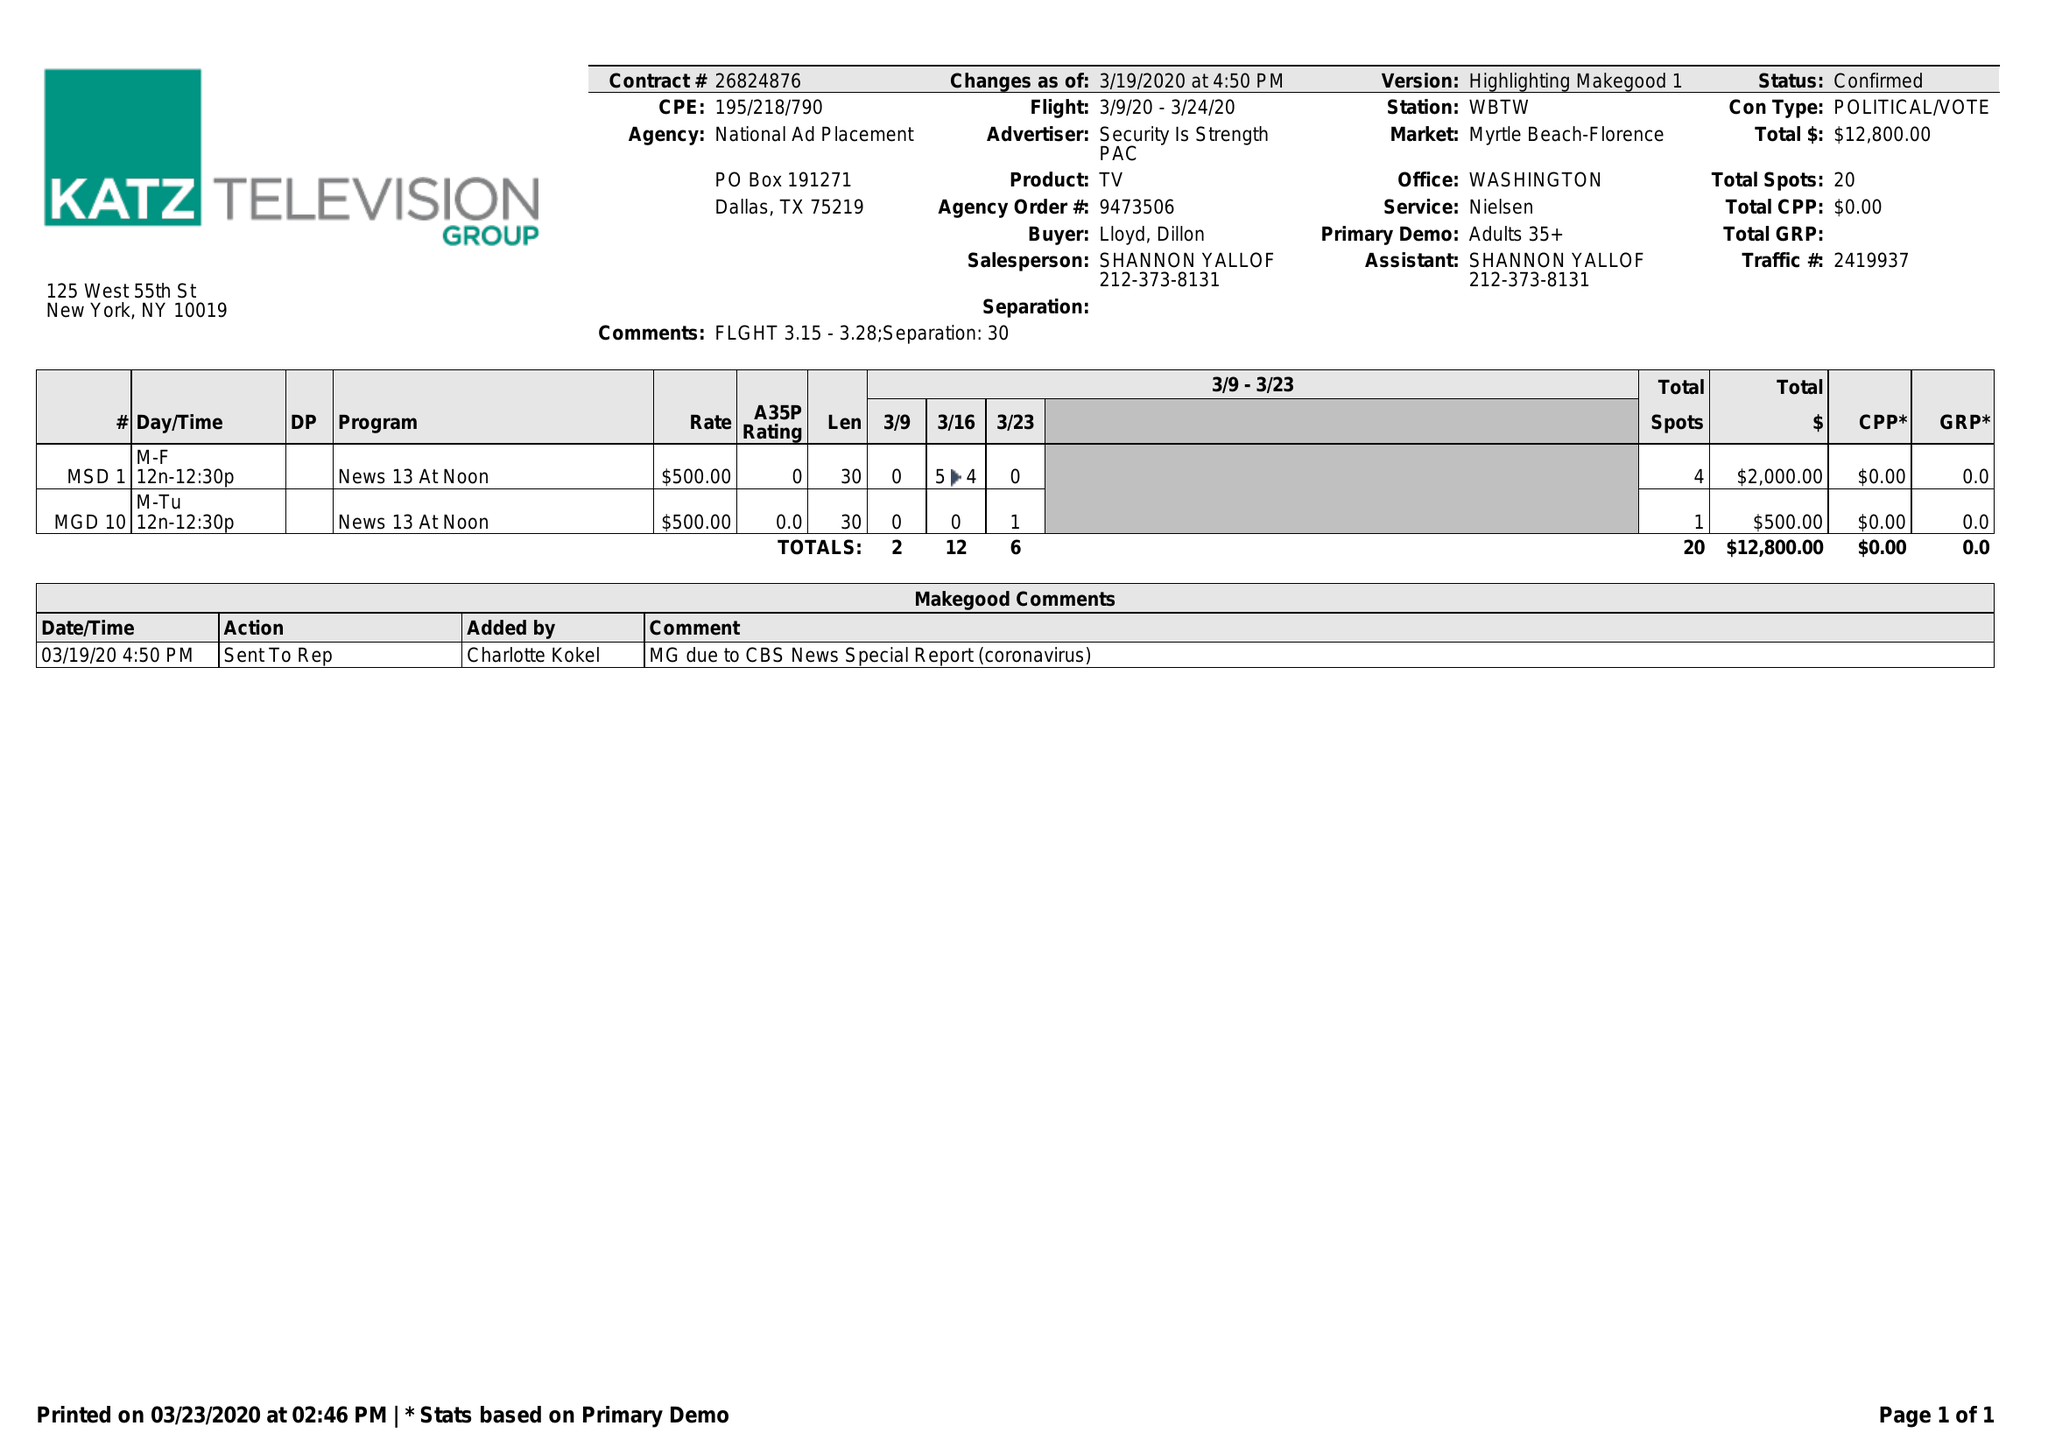What is the value for the gross_amount?
Answer the question using a single word or phrase. 12800.00 